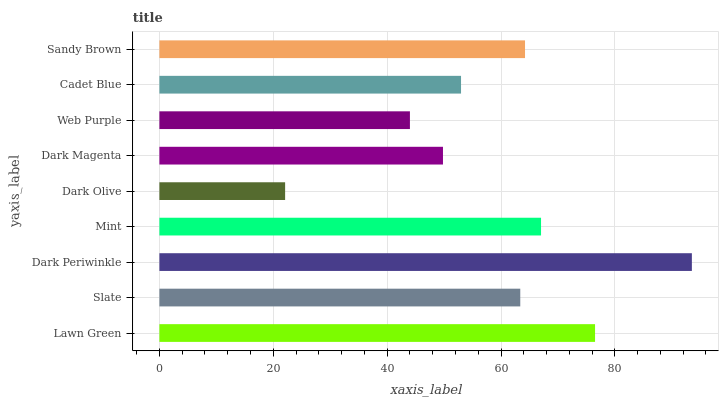Is Dark Olive the minimum?
Answer yes or no. Yes. Is Dark Periwinkle the maximum?
Answer yes or no. Yes. Is Slate the minimum?
Answer yes or no. No. Is Slate the maximum?
Answer yes or no. No. Is Lawn Green greater than Slate?
Answer yes or no. Yes. Is Slate less than Lawn Green?
Answer yes or no. Yes. Is Slate greater than Lawn Green?
Answer yes or no. No. Is Lawn Green less than Slate?
Answer yes or no. No. Is Slate the high median?
Answer yes or no. Yes. Is Slate the low median?
Answer yes or no. Yes. Is Mint the high median?
Answer yes or no. No. Is Lawn Green the low median?
Answer yes or no. No. 